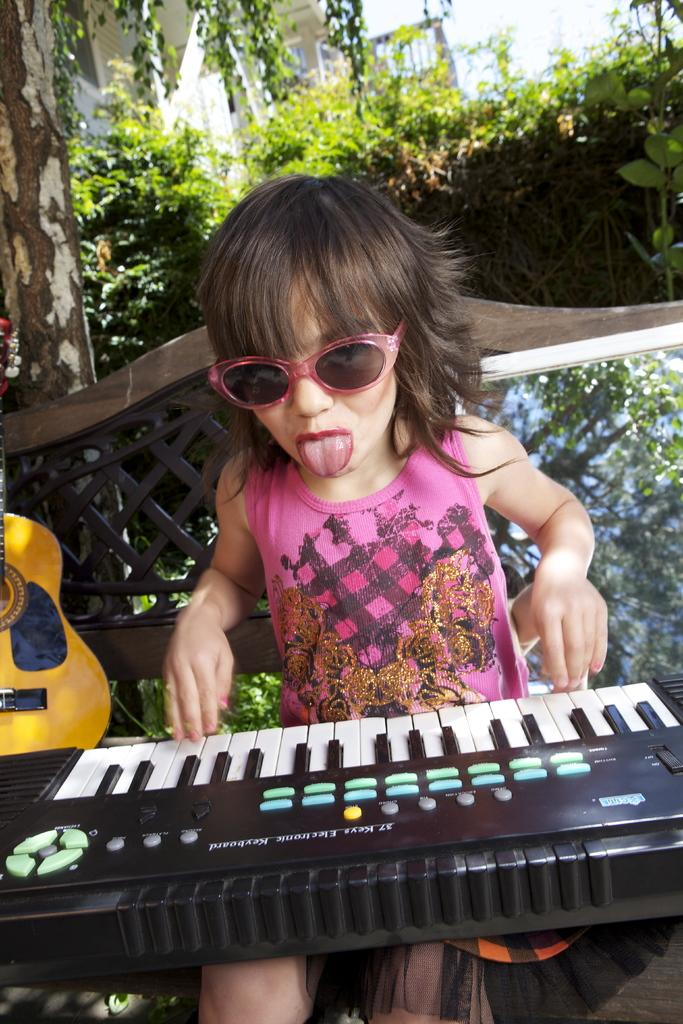Who is the main subject in the image? There is a girl in the image. What is the girl doing in the image? The girl is playing a musical keyboard. What other musical instrument can be seen in the image? There is a guitar in the background of the image. What can be seen in the background of the image besides the guitar? There are trees in the background of the image. What accessory is the girl wearing in the image? The girl is wearing shades. What type of heart-shaped object can be seen on the desk in the image? There is no desk or heart-shaped object present in the image. What committee is the girl a part of in the image? There is no committee or indication of any group involvement in the image. 